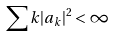Convert formula to latex. <formula><loc_0><loc_0><loc_500><loc_500>\sum k | a _ { k } | ^ { 2 } < \infty</formula> 